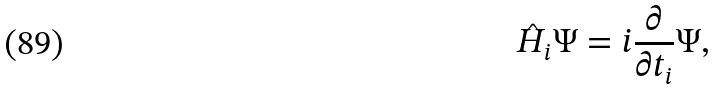Convert formula to latex. <formula><loc_0><loc_0><loc_500><loc_500>\hat { H } _ { i } \Psi = i \frac { \partial } { \partial t _ { i } } \Psi ,</formula> 